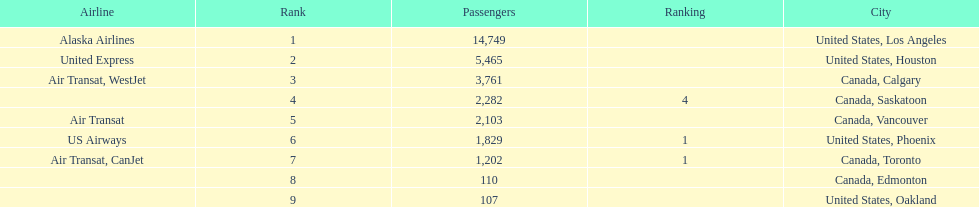What are all the cities? United States, Los Angeles, United States, Houston, Canada, Calgary, Canada, Saskatoon, Canada, Vancouver, United States, Phoenix, Canada, Toronto, Canada, Edmonton, United States, Oakland. How many passengers do they service? 14,749, 5,465, 3,761, 2,282, 2,103, 1,829, 1,202, 110, 107. Which city, when combined with los angeles, totals nearly 19,000? Canada, Calgary. 